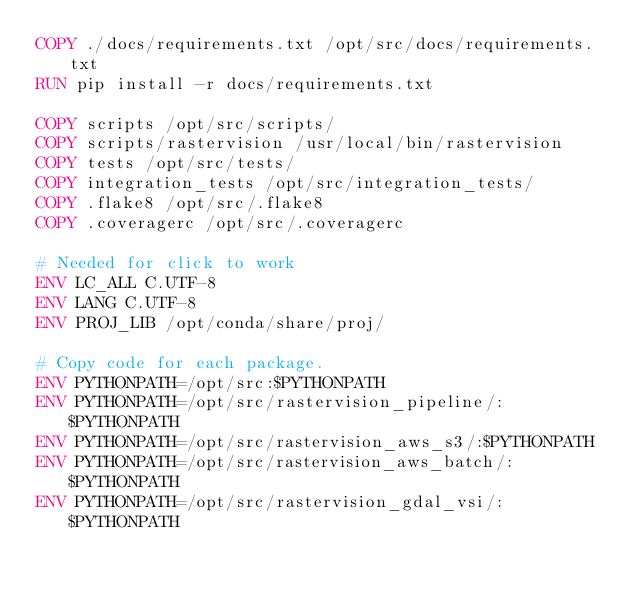<code> <loc_0><loc_0><loc_500><loc_500><_Dockerfile_>COPY ./docs/requirements.txt /opt/src/docs/requirements.txt
RUN pip install -r docs/requirements.txt

COPY scripts /opt/src/scripts/
COPY scripts/rastervision /usr/local/bin/rastervision
COPY tests /opt/src/tests/
COPY integration_tests /opt/src/integration_tests/
COPY .flake8 /opt/src/.flake8
COPY .coveragerc /opt/src/.coveragerc

# Needed for click to work
ENV LC_ALL C.UTF-8
ENV LANG C.UTF-8
ENV PROJ_LIB /opt/conda/share/proj/

# Copy code for each package.
ENV PYTHONPATH=/opt/src:$PYTHONPATH
ENV PYTHONPATH=/opt/src/rastervision_pipeline/:$PYTHONPATH
ENV PYTHONPATH=/opt/src/rastervision_aws_s3/:$PYTHONPATH
ENV PYTHONPATH=/opt/src/rastervision_aws_batch/:$PYTHONPATH
ENV PYTHONPATH=/opt/src/rastervision_gdal_vsi/:$PYTHONPATH</code> 